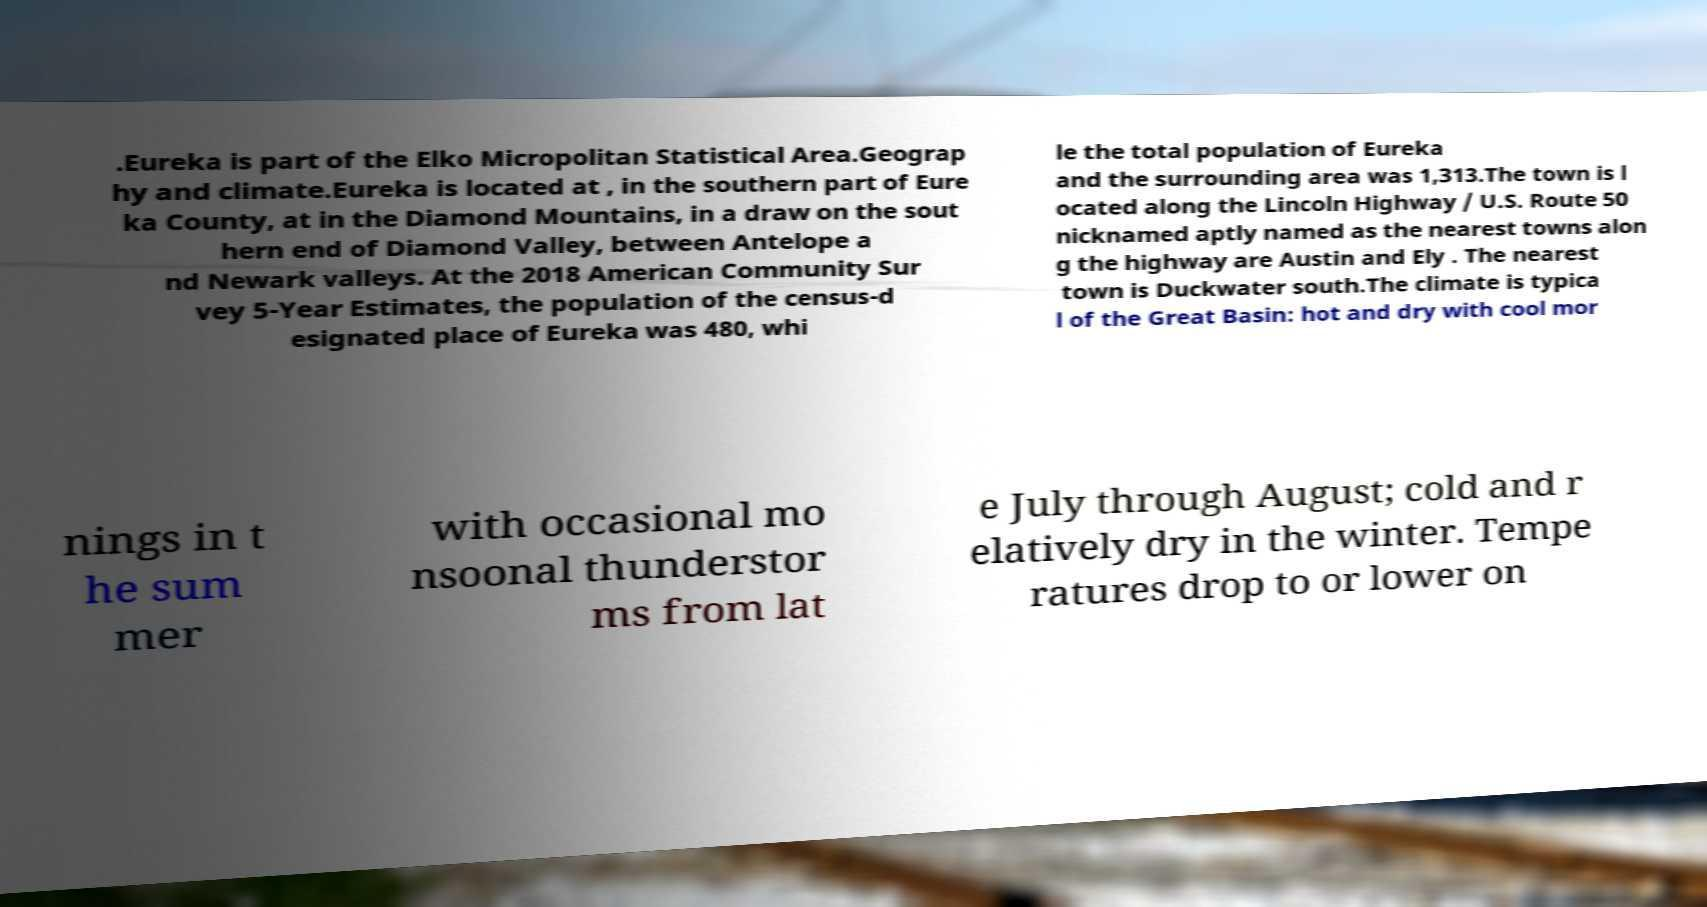Can you accurately transcribe the text from the provided image for me? .Eureka is part of the Elko Micropolitan Statistical Area.Geograp hy and climate.Eureka is located at , in the southern part of Eure ka County, at in the Diamond Mountains, in a draw on the sout hern end of Diamond Valley, between Antelope a nd Newark valleys. At the 2018 American Community Sur vey 5-Year Estimates, the population of the census-d esignated place of Eureka was 480, whi le the total population of Eureka and the surrounding area was 1,313.The town is l ocated along the Lincoln Highway / U.S. Route 50 nicknamed aptly named as the nearest towns alon g the highway are Austin and Ely . The nearest town is Duckwater south.The climate is typica l of the Great Basin: hot and dry with cool mor nings in t he sum mer with occasional mo nsoonal thunderstor ms from lat e July through August; cold and r elatively dry in the winter. Tempe ratures drop to or lower on 